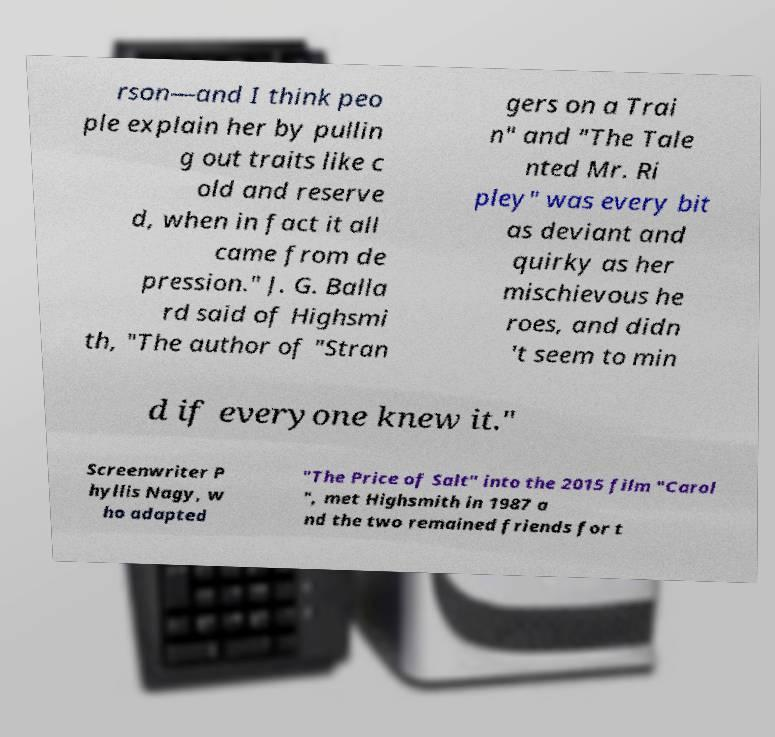For documentation purposes, I need the text within this image transcribed. Could you provide that? rson—and I think peo ple explain her by pullin g out traits like c old and reserve d, when in fact it all came from de pression." J. G. Balla rd said of Highsmi th, "The author of "Stran gers on a Trai n" and "The Tale nted Mr. Ri pley" was every bit as deviant and quirky as her mischievous he roes, and didn 't seem to min d if everyone knew it." Screenwriter P hyllis Nagy, w ho adapted "The Price of Salt" into the 2015 film "Carol ", met Highsmith in 1987 a nd the two remained friends for t 